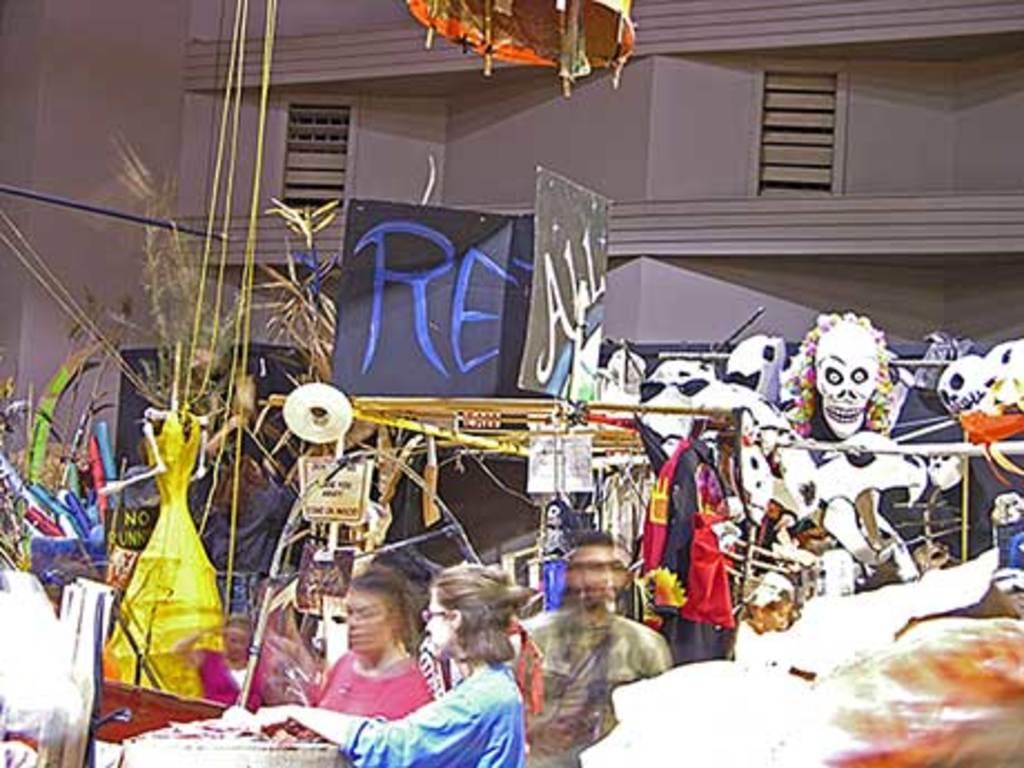In one or two sentences, can you explain what this image depicts? At the bottom of the picture, we see three people are standing. The woman in the blue shirt is holding something in her hands. Beside that, we see a brown table. Behind them, we see many clothes, masks and other items. This might be a stall. In the background, we see a building in grey color. We see boards in blue and grey color with some text written on it. At the bottom of the picture, it is blurred. 